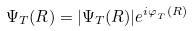<formula> <loc_0><loc_0><loc_500><loc_500>\Psi _ { T } ( R ) = | \Psi _ { T } ( R ) | e ^ { i \varphi _ { _ { T } } ( R ) }</formula> 